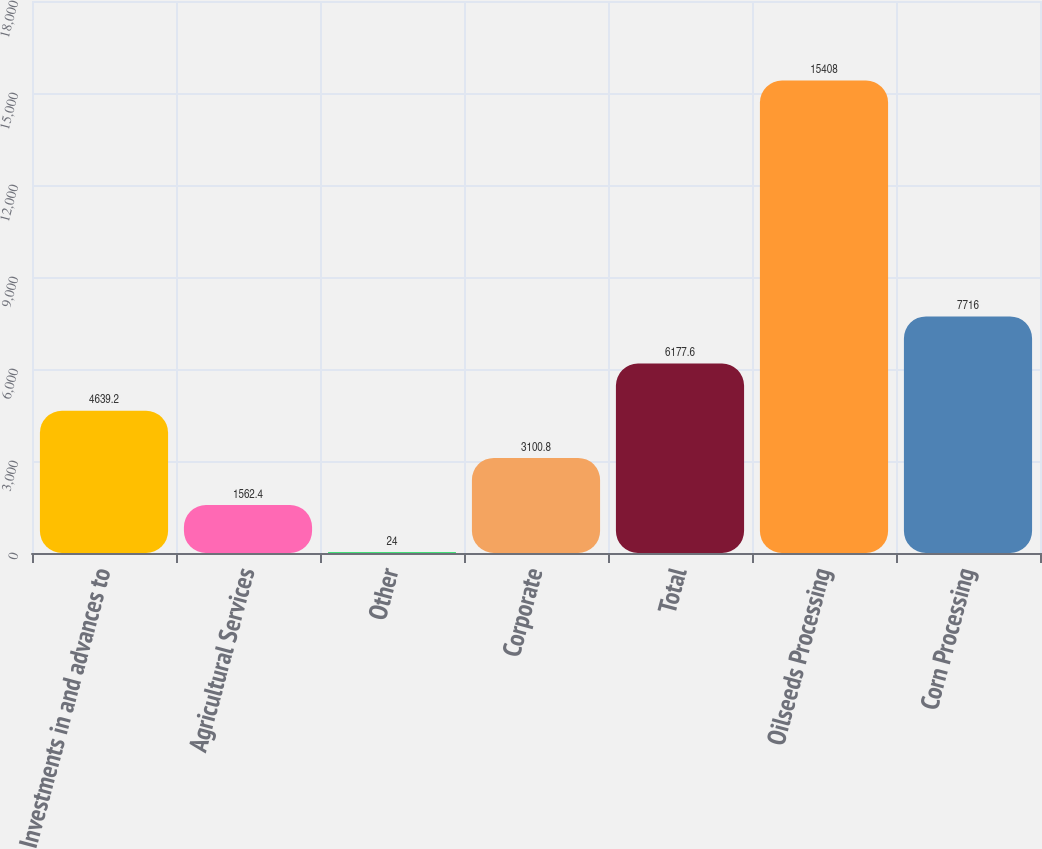Convert chart. <chart><loc_0><loc_0><loc_500><loc_500><bar_chart><fcel>Investments in and advances to<fcel>Agricultural Services<fcel>Other<fcel>Corporate<fcel>Total<fcel>Oilseeds Processing<fcel>Corn Processing<nl><fcel>4639.2<fcel>1562.4<fcel>24<fcel>3100.8<fcel>6177.6<fcel>15408<fcel>7716<nl></chart> 